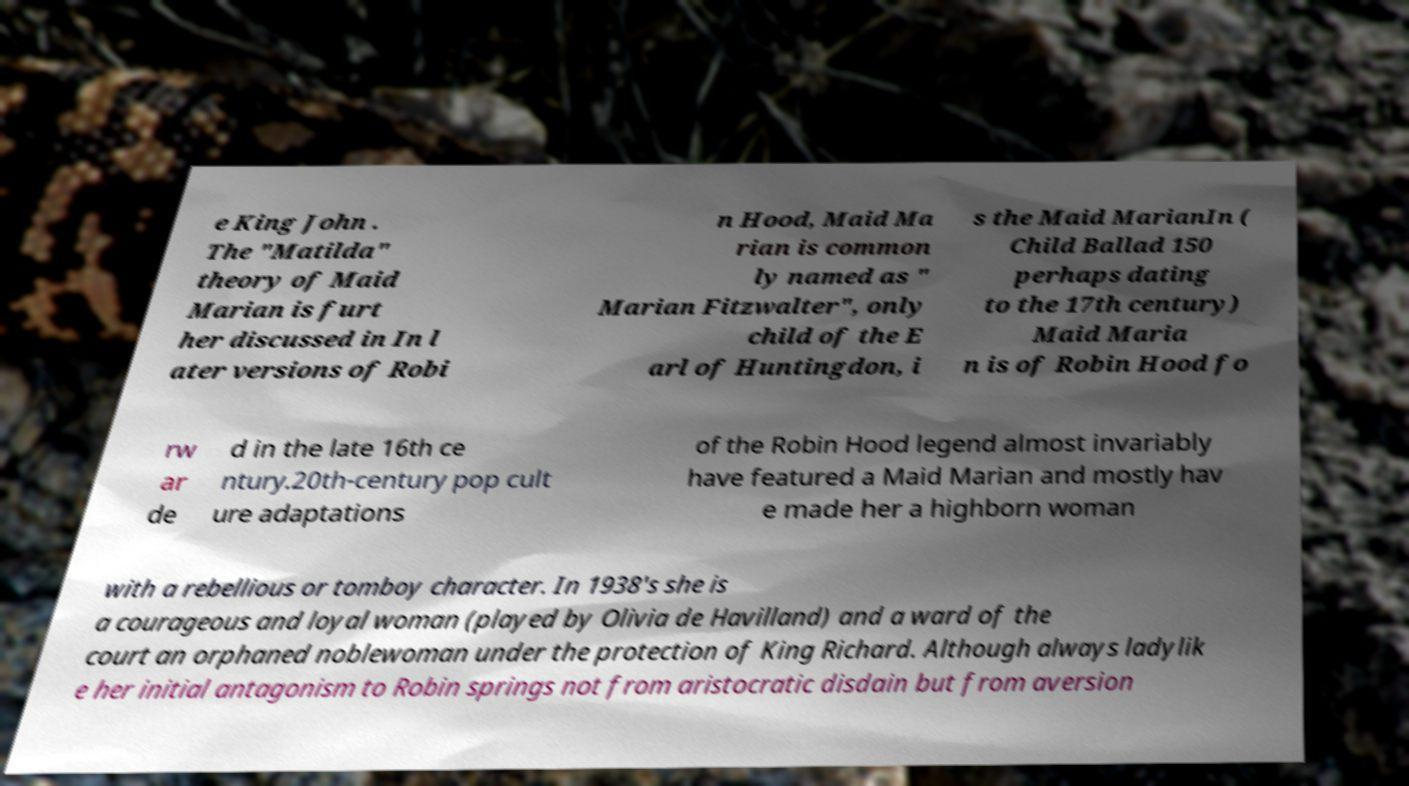What messages or text are displayed in this image? I need them in a readable, typed format. e King John . The "Matilda" theory of Maid Marian is furt her discussed in In l ater versions of Robi n Hood, Maid Ma rian is common ly named as " Marian Fitzwalter", only child of the E arl of Huntingdon, i s the Maid MarianIn ( Child Ballad 150 perhaps dating to the 17th century) Maid Maria n is of Robin Hood fo rw ar de d in the late 16th ce ntury.20th-century pop cult ure adaptations of the Robin Hood legend almost invariably have featured a Maid Marian and mostly hav e made her a highborn woman with a rebellious or tomboy character. In 1938's she is a courageous and loyal woman (played by Olivia de Havilland) and a ward of the court an orphaned noblewoman under the protection of King Richard. Although always ladylik e her initial antagonism to Robin springs not from aristocratic disdain but from aversion 